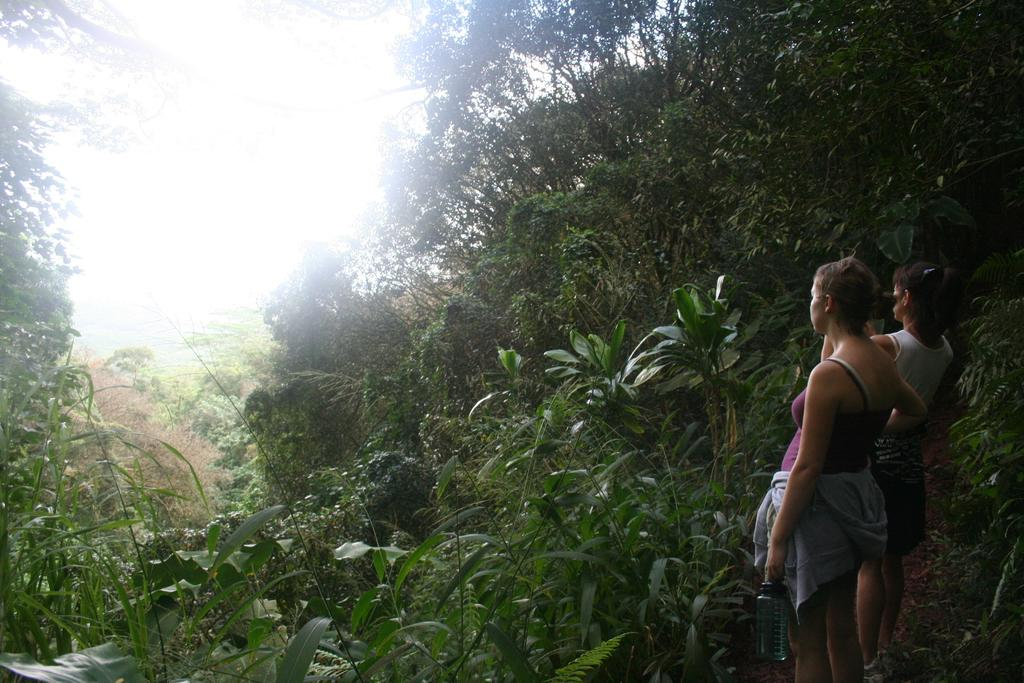How many people are in the image? There are two women in the image. What are the women doing in the image? The women are standing on the ground. What can be seen in the background of the image? There are plants and trees in the background of the image. What type of industry can be seen in the background of the image? There is no industry visible in the image; it features two women standing on the ground with plants and trees in the background. Can you spot a giraffe or a rifle in the image? No, there are no giraffes or rifles present in the image. 